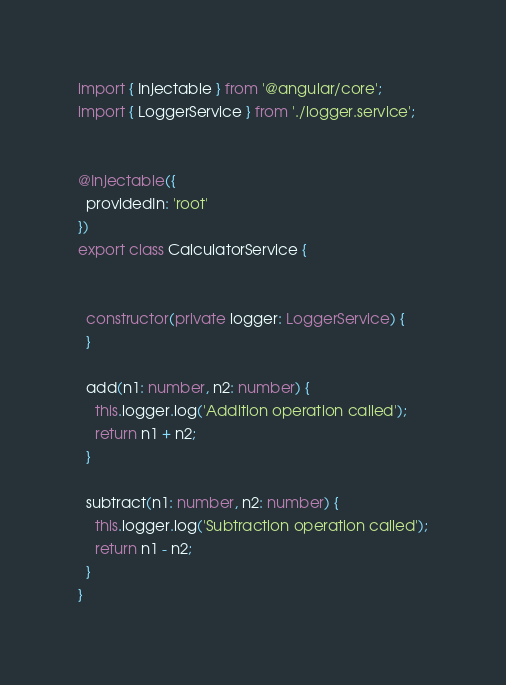Convert code to text. <code><loc_0><loc_0><loc_500><loc_500><_TypeScript_>import { Injectable } from '@angular/core';
import { LoggerService } from './logger.service';


@Injectable({
  providedIn: 'root'
})
export class CalculatorService {


  constructor(private logger: LoggerService) {
  }

  add(n1: number, n2: number) {
    this.logger.log('Addition operation called');
    return n1 + n2;
  }

  subtract(n1: number, n2: number) {
    this.logger.log('Subtraction operation called');
    return n1 - n2;
  }
}

</code> 